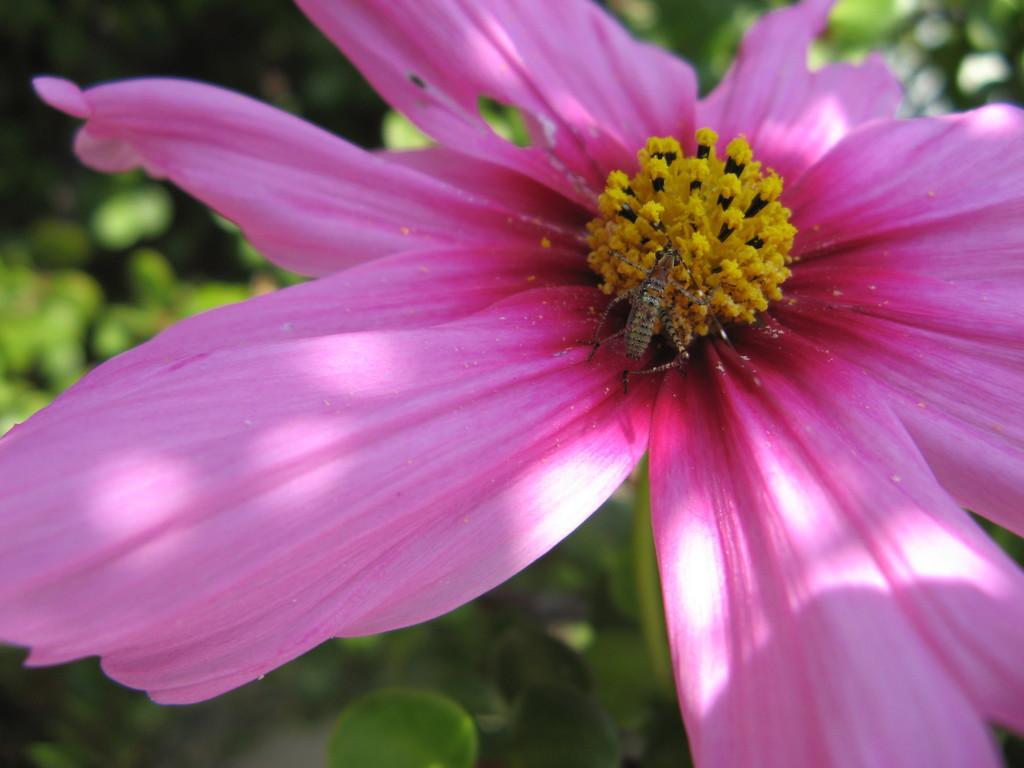In one or two sentences, can you explain what this image depicts? In this picture I can see there is a pink color flower and there is a insect here on the pollen grains and there are some plants in the backdrop. 